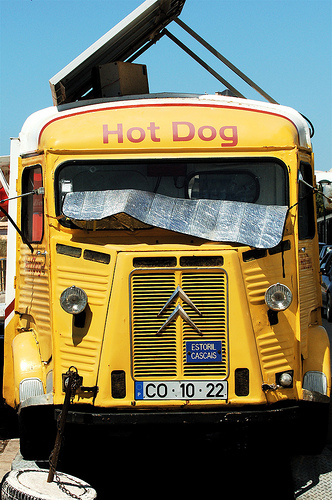<image>
Is there a panel on the hot dog? Yes. Looking at the image, I can see the panel is positioned on top of the hot dog, with the hot dog providing support. 